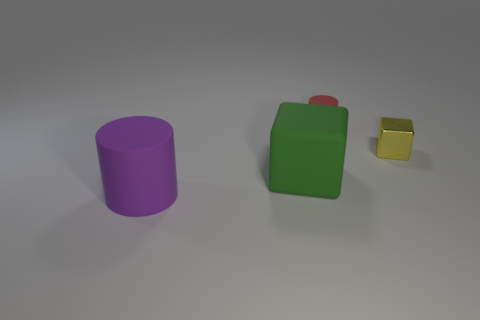Add 4 tiny matte things. How many objects exist? 8 Add 3 yellow shiny cubes. How many yellow shiny cubes are left? 4 Add 4 large matte cylinders. How many large matte cylinders exist? 5 Subtract 0 yellow balls. How many objects are left? 4 Subtract all green objects. Subtract all tiny red rubber things. How many objects are left? 2 